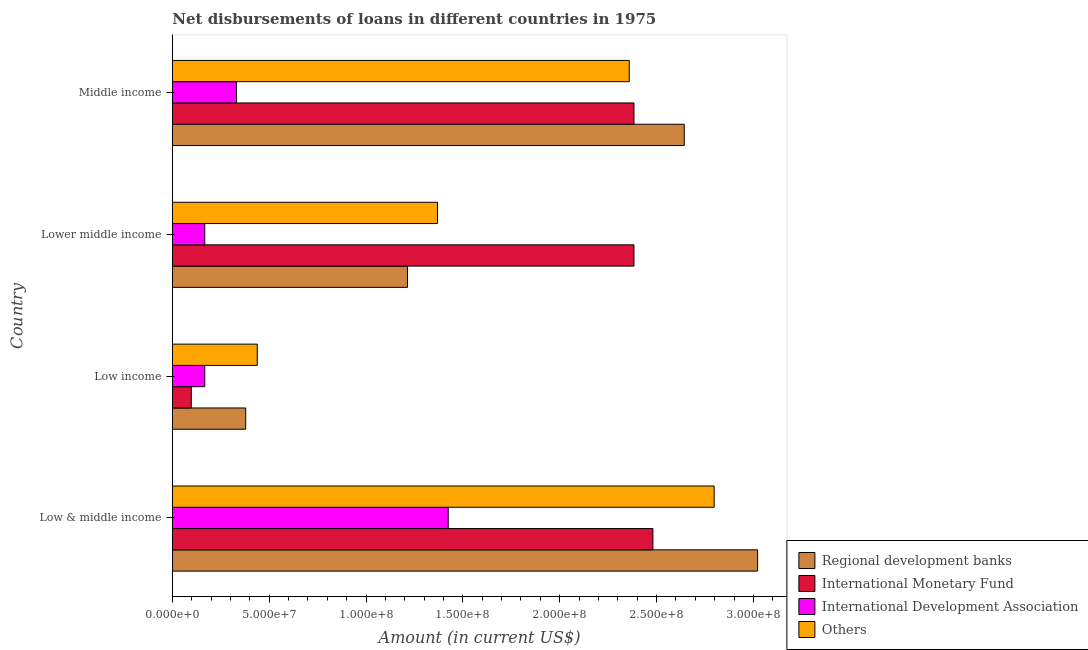How many different coloured bars are there?
Ensure brevity in your answer.  4. Are the number of bars per tick equal to the number of legend labels?
Your answer should be compact. Yes. What is the label of the 2nd group of bars from the top?
Your answer should be compact. Lower middle income. What is the amount of loan disimbursed by international monetary fund in Middle income?
Offer a very short reply. 2.38e+08. Across all countries, what is the maximum amount of loan disimbursed by international development association?
Provide a succinct answer. 1.42e+08. Across all countries, what is the minimum amount of loan disimbursed by international monetary fund?
Provide a succinct answer. 9.77e+06. In which country was the amount of loan disimbursed by international monetary fund maximum?
Your answer should be compact. Low & middle income. What is the total amount of loan disimbursed by other organisations in the graph?
Ensure brevity in your answer.  6.96e+08. What is the difference between the amount of loan disimbursed by other organisations in Low & middle income and that in Lower middle income?
Offer a very short reply. 1.43e+08. What is the difference between the amount of loan disimbursed by international development association in Middle income and the amount of loan disimbursed by other organisations in Low income?
Keep it short and to the point. -1.08e+07. What is the average amount of loan disimbursed by regional development banks per country?
Offer a very short reply. 1.81e+08. What is the difference between the amount of loan disimbursed by international development association and amount of loan disimbursed by regional development banks in Lower middle income?
Ensure brevity in your answer.  -1.05e+08. What is the ratio of the amount of loan disimbursed by regional development banks in Low & middle income to that in Low income?
Your answer should be compact. 7.98. Is the amount of loan disimbursed by international development association in Lower middle income less than that in Middle income?
Give a very brief answer. Yes. Is the difference between the amount of loan disimbursed by other organisations in Low & middle income and Middle income greater than the difference between the amount of loan disimbursed by international monetary fund in Low & middle income and Middle income?
Your answer should be compact. Yes. What is the difference between the highest and the second highest amount of loan disimbursed by international monetary fund?
Offer a very short reply. 9.77e+06. What is the difference between the highest and the lowest amount of loan disimbursed by international monetary fund?
Make the answer very short. 2.38e+08. In how many countries, is the amount of loan disimbursed by international monetary fund greater than the average amount of loan disimbursed by international monetary fund taken over all countries?
Provide a short and direct response. 3. Is it the case that in every country, the sum of the amount of loan disimbursed by regional development banks and amount of loan disimbursed by international monetary fund is greater than the sum of amount of loan disimbursed by other organisations and amount of loan disimbursed by international development association?
Offer a very short reply. No. What does the 4th bar from the top in Middle income represents?
Keep it short and to the point. Regional development banks. What does the 2nd bar from the bottom in Low & middle income represents?
Provide a succinct answer. International Monetary Fund. How many bars are there?
Your response must be concise. 16. How many countries are there in the graph?
Keep it short and to the point. 4. Does the graph contain grids?
Your answer should be very brief. No. Where does the legend appear in the graph?
Your answer should be compact. Bottom right. How many legend labels are there?
Offer a very short reply. 4. How are the legend labels stacked?
Provide a short and direct response. Vertical. What is the title of the graph?
Give a very brief answer. Net disbursements of loans in different countries in 1975. Does "Macroeconomic management" appear as one of the legend labels in the graph?
Keep it short and to the point. No. What is the label or title of the X-axis?
Keep it short and to the point. Amount (in current US$). What is the Amount (in current US$) in Regional development banks in Low & middle income?
Your answer should be compact. 3.02e+08. What is the Amount (in current US$) of International Monetary Fund in Low & middle income?
Make the answer very short. 2.48e+08. What is the Amount (in current US$) in International Development Association in Low & middle income?
Your answer should be compact. 1.42e+08. What is the Amount (in current US$) of Others in Low & middle income?
Make the answer very short. 2.80e+08. What is the Amount (in current US$) of Regional development banks in Low income?
Keep it short and to the point. 3.79e+07. What is the Amount (in current US$) in International Monetary Fund in Low income?
Offer a very short reply. 9.77e+06. What is the Amount (in current US$) of International Development Association in Low income?
Provide a succinct answer. 1.67e+07. What is the Amount (in current US$) of Others in Low income?
Your response must be concise. 4.38e+07. What is the Amount (in current US$) in Regional development banks in Lower middle income?
Make the answer very short. 1.21e+08. What is the Amount (in current US$) of International Monetary Fund in Lower middle income?
Offer a very short reply. 2.38e+08. What is the Amount (in current US$) in International Development Association in Lower middle income?
Your response must be concise. 1.67e+07. What is the Amount (in current US$) of Others in Lower middle income?
Provide a short and direct response. 1.37e+08. What is the Amount (in current US$) of Regional development banks in Middle income?
Your response must be concise. 2.64e+08. What is the Amount (in current US$) in International Monetary Fund in Middle income?
Make the answer very short. 2.38e+08. What is the Amount (in current US$) of International Development Association in Middle income?
Make the answer very short. 3.31e+07. What is the Amount (in current US$) in Others in Middle income?
Offer a very short reply. 2.36e+08. Across all countries, what is the maximum Amount (in current US$) of Regional development banks?
Provide a succinct answer. 3.02e+08. Across all countries, what is the maximum Amount (in current US$) in International Monetary Fund?
Ensure brevity in your answer.  2.48e+08. Across all countries, what is the maximum Amount (in current US$) of International Development Association?
Your answer should be compact. 1.42e+08. Across all countries, what is the maximum Amount (in current US$) in Others?
Your answer should be compact. 2.80e+08. Across all countries, what is the minimum Amount (in current US$) of Regional development banks?
Ensure brevity in your answer.  3.79e+07. Across all countries, what is the minimum Amount (in current US$) of International Monetary Fund?
Your response must be concise. 9.77e+06. Across all countries, what is the minimum Amount (in current US$) in International Development Association?
Your response must be concise. 1.67e+07. Across all countries, what is the minimum Amount (in current US$) of Others?
Ensure brevity in your answer.  4.38e+07. What is the total Amount (in current US$) in Regional development banks in the graph?
Your response must be concise. 7.26e+08. What is the total Amount (in current US$) of International Monetary Fund in the graph?
Offer a terse response. 7.35e+08. What is the total Amount (in current US$) of International Development Association in the graph?
Keep it short and to the point. 2.09e+08. What is the total Amount (in current US$) of Others in the graph?
Give a very brief answer. 6.96e+08. What is the difference between the Amount (in current US$) in Regional development banks in Low & middle income and that in Low income?
Make the answer very short. 2.64e+08. What is the difference between the Amount (in current US$) in International Monetary Fund in Low & middle income and that in Low income?
Provide a short and direct response. 2.38e+08. What is the difference between the Amount (in current US$) of International Development Association in Low & middle income and that in Low income?
Provide a short and direct response. 1.26e+08. What is the difference between the Amount (in current US$) in Others in Low & middle income and that in Low income?
Provide a short and direct response. 2.36e+08. What is the difference between the Amount (in current US$) in Regional development banks in Low & middle income and that in Lower middle income?
Give a very brief answer. 1.81e+08. What is the difference between the Amount (in current US$) in International Monetary Fund in Low & middle income and that in Lower middle income?
Provide a short and direct response. 9.77e+06. What is the difference between the Amount (in current US$) of International Development Association in Low & middle income and that in Lower middle income?
Your answer should be compact. 1.26e+08. What is the difference between the Amount (in current US$) in Others in Low & middle income and that in Lower middle income?
Your answer should be compact. 1.43e+08. What is the difference between the Amount (in current US$) in Regional development banks in Low & middle income and that in Middle income?
Offer a terse response. 3.79e+07. What is the difference between the Amount (in current US$) of International Monetary Fund in Low & middle income and that in Middle income?
Offer a terse response. 9.77e+06. What is the difference between the Amount (in current US$) in International Development Association in Low & middle income and that in Middle income?
Your answer should be very brief. 1.09e+08. What is the difference between the Amount (in current US$) of Others in Low & middle income and that in Middle income?
Your response must be concise. 4.38e+07. What is the difference between the Amount (in current US$) in Regional development banks in Low income and that in Lower middle income?
Make the answer very short. -8.35e+07. What is the difference between the Amount (in current US$) in International Monetary Fund in Low income and that in Lower middle income?
Offer a very short reply. -2.29e+08. What is the difference between the Amount (in current US$) of Others in Low income and that in Lower middle income?
Your answer should be compact. -9.31e+07. What is the difference between the Amount (in current US$) in Regional development banks in Low income and that in Middle income?
Offer a very short reply. -2.26e+08. What is the difference between the Amount (in current US$) of International Monetary Fund in Low income and that in Middle income?
Provide a short and direct response. -2.29e+08. What is the difference between the Amount (in current US$) in International Development Association in Low income and that in Middle income?
Your response must be concise. -1.63e+07. What is the difference between the Amount (in current US$) of Others in Low income and that in Middle income?
Ensure brevity in your answer.  -1.92e+08. What is the difference between the Amount (in current US$) in Regional development banks in Lower middle income and that in Middle income?
Ensure brevity in your answer.  -1.43e+08. What is the difference between the Amount (in current US$) of International Monetary Fund in Lower middle income and that in Middle income?
Your response must be concise. 0. What is the difference between the Amount (in current US$) in International Development Association in Lower middle income and that in Middle income?
Provide a succinct answer. -1.63e+07. What is the difference between the Amount (in current US$) of Others in Lower middle income and that in Middle income?
Give a very brief answer. -9.90e+07. What is the difference between the Amount (in current US$) of Regional development banks in Low & middle income and the Amount (in current US$) of International Monetary Fund in Low income?
Offer a very short reply. 2.92e+08. What is the difference between the Amount (in current US$) in Regional development banks in Low & middle income and the Amount (in current US$) in International Development Association in Low income?
Provide a short and direct response. 2.85e+08. What is the difference between the Amount (in current US$) in Regional development banks in Low & middle income and the Amount (in current US$) in Others in Low income?
Your response must be concise. 2.58e+08. What is the difference between the Amount (in current US$) in International Monetary Fund in Low & middle income and the Amount (in current US$) in International Development Association in Low income?
Give a very brief answer. 2.31e+08. What is the difference between the Amount (in current US$) in International Monetary Fund in Low & middle income and the Amount (in current US$) in Others in Low income?
Your response must be concise. 2.04e+08. What is the difference between the Amount (in current US$) in International Development Association in Low & middle income and the Amount (in current US$) in Others in Low income?
Offer a very short reply. 9.86e+07. What is the difference between the Amount (in current US$) of Regional development banks in Low & middle income and the Amount (in current US$) of International Monetary Fund in Lower middle income?
Give a very brief answer. 6.38e+07. What is the difference between the Amount (in current US$) of Regional development banks in Low & middle income and the Amount (in current US$) of International Development Association in Lower middle income?
Your answer should be very brief. 2.85e+08. What is the difference between the Amount (in current US$) of Regional development banks in Low & middle income and the Amount (in current US$) of Others in Lower middle income?
Ensure brevity in your answer.  1.65e+08. What is the difference between the Amount (in current US$) in International Monetary Fund in Low & middle income and the Amount (in current US$) in International Development Association in Lower middle income?
Give a very brief answer. 2.31e+08. What is the difference between the Amount (in current US$) of International Monetary Fund in Low & middle income and the Amount (in current US$) of Others in Lower middle income?
Provide a short and direct response. 1.11e+08. What is the difference between the Amount (in current US$) in International Development Association in Low & middle income and the Amount (in current US$) in Others in Lower middle income?
Provide a short and direct response. 5.54e+06. What is the difference between the Amount (in current US$) of Regional development banks in Low & middle income and the Amount (in current US$) of International Monetary Fund in Middle income?
Offer a terse response. 6.38e+07. What is the difference between the Amount (in current US$) in Regional development banks in Low & middle income and the Amount (in current US$) in International Development Association in Middle income?
Make the answer very short. 2.69e+08. What is the difference between the Amount (in current US$) of Regional development banks in Low & middle income and the Amount (in current US$) of Others in Middle income?
Your answer should be very brief. 6.63e+07. What is the difference between the Amount (in current US$) of International Monetary Fund in Low & middle income and the Amount (in current US$) of International Development Association in Middle income?
Your answer should be compact. 2.15e+08. What is the difference between the Amount (in current US$) in International Monetary Fund in Low & middle income and the Amount (in current US$) in Others in Middle income?
Give a very brief answer. 1.22e+07. What is the difference between the Amount (in current US$) of International Development Association in Low & middle income and the Amount (in current US$) of Others in Middle income?
Provide a succinct answer. -9.35e+07. What is the difference between the Amount (in current US$) of Regional development banks in Low income and the Amount (in current US$) of International Monetary Fund in Lower middle income?
Your response must be concise. -2.00e+08. What is the difference between the Amount (in current US$) in Regional development banks in Low income and the Amount (in current US$) in International Development Association in Lower middle income?
Ensure brevity in your answer.  2.11e+07. What is the difference between the Amount (in current US$) in Regional development banks in Low income and the Amount (in current US$) in Others in Lower middle income?
Ensure brevity in your answer.  -9.90e+07. What is the difference between the Amount (in current US$) of International Monetary Fund in Low income and the Amount (in current US$) of International Development Association in Lower middle income?
Keep it short and to the point. -6.96e+06. What is the difference between the Amount (in current US$) in International Monetary Fund in Low income and the Amount (in current US$) in Others in Lower middle income?
Provide a short and direct response. -1.27e+08. What is the difference between the Amount (in current US$) of International Development Association in Low income and the Amount (in current US$) of Others in Lower middle income?
Provide a succinct answer. -1.20e+08. What is the difference between the Amount (in current US$) in Regional development banks in Low income and the Amount (in current US$) in International Monetary Fund in Middle income?
Make the answer very short. -2.00e+08. What is the difference between the Amount (in current US$) in Regional development banks in Low income and the Amount (in current US$) in International Development Association in Middle income?
Give a very brief answer. 4.80e+06. What is the difference between the Amount (in current US$) in Regional development banks in Low income and the Amount (in current US$) in Others in Middle income?
Provide a short and direct response. -1.98e+08. What is the difference between the Amount (in current US$) in International Monetary Fund in Low income and the Amount (in current US$) in International Development Association in Middle income?
Your answer should be compact. -2.33e+07. What is the difference between the Amount (in current US$) of International Monetary Fund in Low income and the Amount (in current US$) of Others in Middle income?
Ensure brevity in your answer.  -2.26e+08. What is the difference between the Amount (in current US$) in International Development Association in Low income and the Amount (in current US$) in Others in Middle income?
Offer a terse response. -2.19e+08. What is the difference between the Amount (in current US$) of Regional development banks in Lower middle income and the Amount (in current US$) of International Monetary Fund in Middle income?
Your response must be concise. -1.17e+08. What is the difference between the Amount (in current US$) in Regional development banks in Lower middle income and the Amount (in current US$) in International Development Association in Middle income?
Keep it short and to the point. 8.83e+07. What is the difference between the Amount (in current US$) in Regional development banks in Lower middle income and the Amount (in current US$) in Others in Middle income?
Give a very brief answer. -1.15e+08. What is the difference between the Amount (in current US$) in International Monetary Fund in Lower middle income and the Amount (in current US$) in International Development Association in Middle income?
Make the answer very short. 2.05e+08. What is the difference between the Amount (in current US$) in International Monetary Fund in Lower middle income and the Amount (in current US$) in Others in Middle income?
Give a very brief answer. 2.43e+06. What is the difference between the Amount (in current US$) in International Development Association in Lower middle income and the Amount (in current US$) in Others in Middle income?
Make the answer very short. -2.19e+08. What is the average Amount (in current US$) in Regional development banks per country?
Offer a terse response. 1.81e+08. What is the average Amount (in current US$) in International Monetary Fund per country?
Ensure brevity in your answer.  1.84e+08. What is the average Amount (in current US$) in International Development Association per country?
Offer a terse response. 5.22e+07. What is the average Amount (in current US$) of Others per country?
Your answer should be very brief. 1.74e+08. What is the difference between the Amount (in current US$) in Regional development banks and Amount (in current US$) in International Monetary Fund in Low & middle income?
Make the answer very short. 5.41e+07. What is the difference between the Amount (in current US$) in Regional development banks and Amount (in current US$) in International Development Association in Low & middle income?
Give a very brief answer. 1.60e+08. What is the difference between the Amount (in current US$) in Regional development banks and Amount (in current US$) in Others in Low & middle income?
Provide a short and direct response. 2.24e+07. What is the difference between the Amount (in current US$) in International Monetary Fund and Amount (in current US$) in International Development Association in Low & middle income?
Ensure brevity in your answer.  1.06e+08. What is the difference between the Amount (in current US$) in International Monetary Fund and Amount (in current US$) in Others in Low & middle income?
Offer a terse response. -3.16e+07. What is the difference between the Amount (in current US$) in International Development Association and Amount (in current US$) in Others in Low & middle income?
Make the answer very short. -1.37e+08. What is the difference between the Amount (in current US$) in Regional development banks and Amount (in current US$) in International Monetary Fund in Low income?
Ensure brevity in your answer.  2.81e+07. What is the difference between the Amount (in current US$) in Regional development banks and Amount (in current US$) in International Development Association in Low income?
Keep it short and to the point. 2.11e+07. What is the difference between the Amount (in current US$) of Regional development banks and Amount (in current US$) of Others in Low income?
Offer a terse response. -5.96e+06. What is the difference between the Amount (in current US$) of International Monetary Fund and Amount (in current US$) of International Development Association in Low income?
Offer a terse response. -6.96e+06. What is the difference between the Amount (in current US$) in International Monetary Fund and Amount (in current US$) in Others in Low income?
Your response must be concise. -3.41e+07. What is the difference between the Amount (in current US$) in International Development Association and Amount (in current US$) in Others in Low income?
Offer a terse response. -2.71e+07. What is the difference between the Amount (in current US$) of Regional development banks and Amount (in current US$) of International Monetary Fund in Lower middle income?
Your answer should be compact. -1.17e+08. What is the difference between the Amount (in current US$) in Regional development banks and Amount (in current US$) in International Development Association in Lower middle income?
Keep it short and to the point. 1.05e+08. What is the difference between the Amount (in current US$) in Regional development banks and Amount (in current US$) in Others in Lower middle income?
Your answer should be very brief. -1.55e+07. What is the difference between the Amount (in current US$) in International Monetary Fund and Amount (in current US$) in International Development Association in Lower middle income?
Your answer should be very brief. 2.22e+08. What is the difference between the Amount (in current US$) of International Monetary Fund and Amount (in current US$) of Others in Lower middle income?
Your answer should be very brief. 1.01e+08. What is the difference between the Amount (in current US$) in International Development Association and Amount (in current US$) in Others in Lower middle income?
Offer a very short reply. -1.20e+08. What is the difference between the Amount (in current US$) in Regional development banks and Amount (in current US$) in International Monetary Fund in Middle income?
Your response must be concise. 2.60e+07. What is the difference between the Amount (in current US$) of Regional development banks and Amount (in current US$) of International Development Association in Middle income?
Offer a terse response. 2.31e+08. What is the difference between the Amount (in current US$) in Regional development banks and Amount (in current US$) in Others in Middle income?
Provide a short and direct response. 2.84e+07. What is the difference between the Amount (in current US$) in International Monetary Fund and Amount (in current US$) in International Development Association in Middle income?
Your answer should be compact. 2.05e+08. What is the difference between the Amount (in current US$) of International Monetary Fund and Amount (in current US$) of Others in Middle income?
Provide a succinct answer. 2.43e+06. What is the difference between the Amount (in current US$) in International Development Association and Amount (in current US$) in Others in Middle income?
Give a very brief answer. -2.03e+08. What is the ratio of the Amount (in current US$) of Regional development banks in Low & middle income to that in Low income?
Provide a short and direct response. 7.98. What is the ratio of the Amount (in current US$) of International Monetary Fund in Low & middle income to that in Low income?
Your answer should be very brief. 25.4. What is the ratio of the Amount (in current US$) in International Development Association in Low & middle income to that in Low income?
Offer a very short reply. 8.51. What is the ratio of the Amount (in current US$) in Others in Low & middle income to that in Low income?
Give a very brief answer. 6.38. What is the ratio of the Amount (in current US$) of Regional development banks in Low & middle income to that in Lower middle income?
Give a very brief answer. 2.49. What is the ratio of the Amount (in current US$) of International Monetary Fund in Low & middle income to that in Lower middle income?
Offer a very short reply. 1.04. What is the ratio of the Amount (in current US$) of International Development Association in Low & middle income to that in Lower middle income?
Provide a short and direct response. 8.51. What is the ratio of the Amount (in current US$) of Others in Low & middle income to that in Lower middle income?
Keep it short and to the point. 2.04. What is the ratio of the Amount (in current US$) in Regional development banks in Low & middle income to that in Middle income?
Your response must be concise. 1.14. What is the ratio of the Amount (in current US$) of International Monetary Fund in Low & middle income to that in Middle income?
Keep it short and to the point. 1.04. What is the ratio of the Amount (in current US$) in International Development Association in Low & middle income to that in Middle income?
Provide a succinct answer. 4.31. What is the ratio of the Amount (in current US$) of Others in Low & middle income to that in Middle income?
Keep it short and to the point. 1.19. What is the ratio of the Amount (in current US$) in Regional development banks in Low income to that in Lower middle income?
Your answer should be compact. 0.31. What is the ratio of the Amount (in current US$) in International Monetary Fund in Low income to that in Lower middle income?
Offer a very short reply. 0.04. What is the ratio of the Amount (in current US$) in International Development Association in Low income to that in Lower middle income?
Provide a succinct answer. 1. What is the ratio of the Amount (in current US$) of Others in Low income to that in Lower middle income?
Provide a succinct answer. 0.32. What is the ratio of the Amount (in current US$) in Regional development banks in Low income to that in Middle income?
Give a very brief answer. 0.14. What is the ratio of the Amount (in current US$) of International Monetary Fund in Low income to that in Middle income?
Give a very brief answer. 0.04. What is the ratio of the Amount (in current US$) of International Development Association in Low income to that in Middle income?
Offer a terse response. 0.51. What is the ratio of the Amount (in current US$) of Others in Low income to that in Middle income?
Offer a terse response. 0.19. What is the ratio of the Amount (in current US$) in Regional development banks in Lower middle income to that in Middle income?
Offer a terse response. 0.46. What is the ratio of the Amount (in current US$) in International Development Association in Lower middle income to that in Middle income?
Give a very brief answer. 0.51. What is the ratio of the Amount (in current US$) in Others in Lower middle income to that in Middle income?
Offer a very short reply. 0.58. What is the difference between the highest and the second highest Amount (in current US$) in Regional development banks?
Offer a terse response. 3.79e+07. What is the difference between the highest and the second highest Amount (in current US$) in International Monetary Fund?
Offer a very short reply. 9.77e+06. What is the difference between the highest and the second highest Amount (in current US$) of International Development Association?
Your answer should be very brief. 1.09e+08. What is the difference between the highest and the second highest Amount (in current US$) of Others?
Your response must be concise. 4.38e+07. What is the difference between the highest and the lowest Amount (in current US$) in Regional development banks?
Provide a succinct answer. 2.64e+08. What is the difference between the highest and the lowest Amount (in current US$) in International Monetary Fund?
Make the answer very short. 2.38e+08. What is the difference between the highest and the lowest Amount (in current US$) of International Development Association?
Your answer should be very brief. 1.26e+08. What is the difference between the highest and the lowest Amount (in current US$) in Others?
Your answer should be very brief. 2.36e+08. 